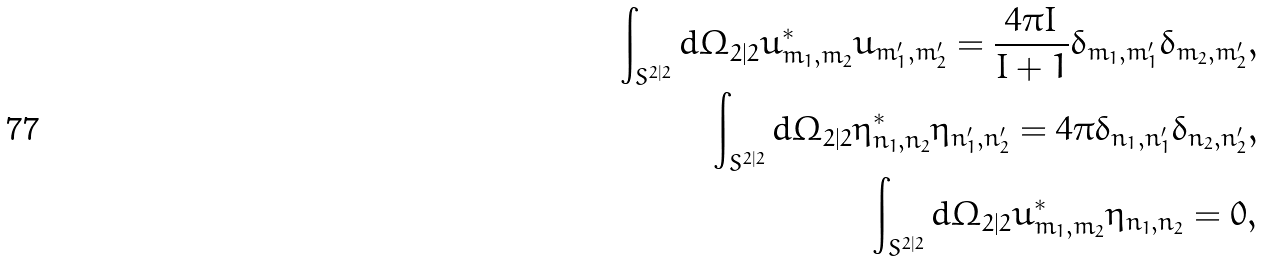Convert formula to latex. <formula><loc_0><loc_0><loc_500><loc_500>\int _ { S ^ { 2 | 2 } } d \Omega _ { 2 | 2 } u _ { m _ { 1 } , m _ { 2 } } ^ { * } u _ { m ^ { \prime } _ { 1 } , m ^ { \prime } _ { 2 } } = \frac { 4 \pi I } { I + 1 } \delta _ { m _ { 1 } , m ^ { \prime } _ { 1 } } \delta _ { m _ { 2 } , m ^ { \prime } _ { 2 } } , \\ \int _ { S ^ { 2 | 2 } } d \Omega _ { 2 | 2 } \eta _ { n _ { 1 } , n _ { 2 } } ^ { * } \eta _ { n ^ { \prime } _ { 1 } , n ^ { \prime } _ { 2 } } = 4 \pi \delta _ { n _ { 1 } , n ^ { \prime } _ { 1 } } \delta _ { n _ { 2 } , n ^ { \prime } _ { 2 } } , \\ \int _ { S ^ { 2 | 2 } } d \Omega _ { 2 | 2 } u _ { m _ { 1 } , m _ { 2 } } ^ { * } \eta _ { n _ { 1 } , n _ { 2 } } = 0 ,</formula> 